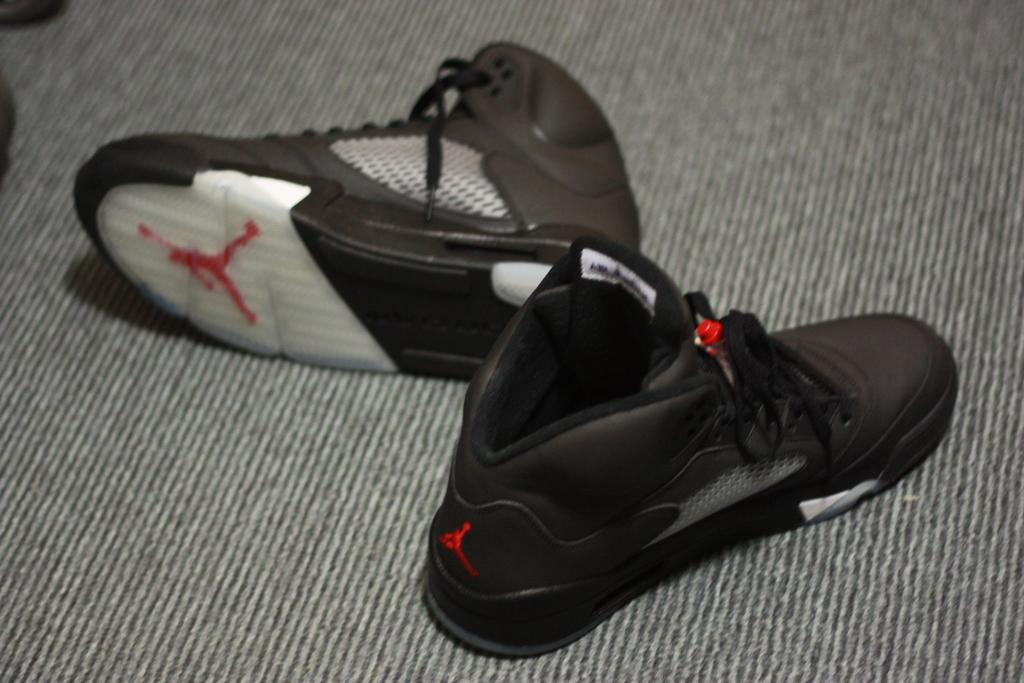What type of footwear is visible in the image? There is a pair of shoes in the shoes in the image. Where are the shoes located? The shoes are on a carpet. What riddle is the pair of shoes trying to solve in the image? There is no riddle present in the image; it simply shows a pair of shoes on a carpet. 